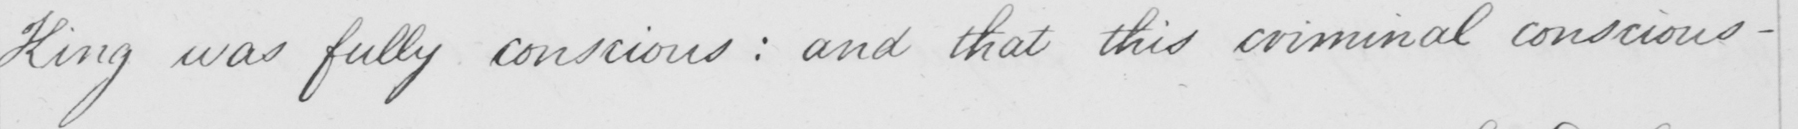Please provide the text content of this handwritten line. King was fully conscious :  and that this criminal conscious- 